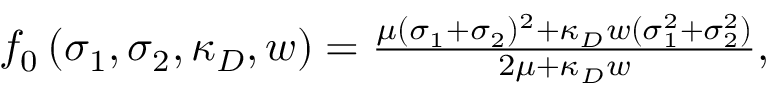Convert formula to latex. <formula><loc_0><loc_0><loc_500><loc_500>\begin{array} { r } { f _ { 0 } \left ( \sigma _ { 1 } , \sigma _ { 2 } , \kappa _ { D } , w \right ) = \frac { \mu ( \sigma _ { 1 } + \sigma _ { 2 } ) ^ { 2 } + \kappa _ { D } w ( \sigma _ { 1 } ^ { 2 } + \sigma _ { 2 } ^ { 2 } ) } { 2 \mu + \kappa _ { D } w } , } \end{array}</formula> 